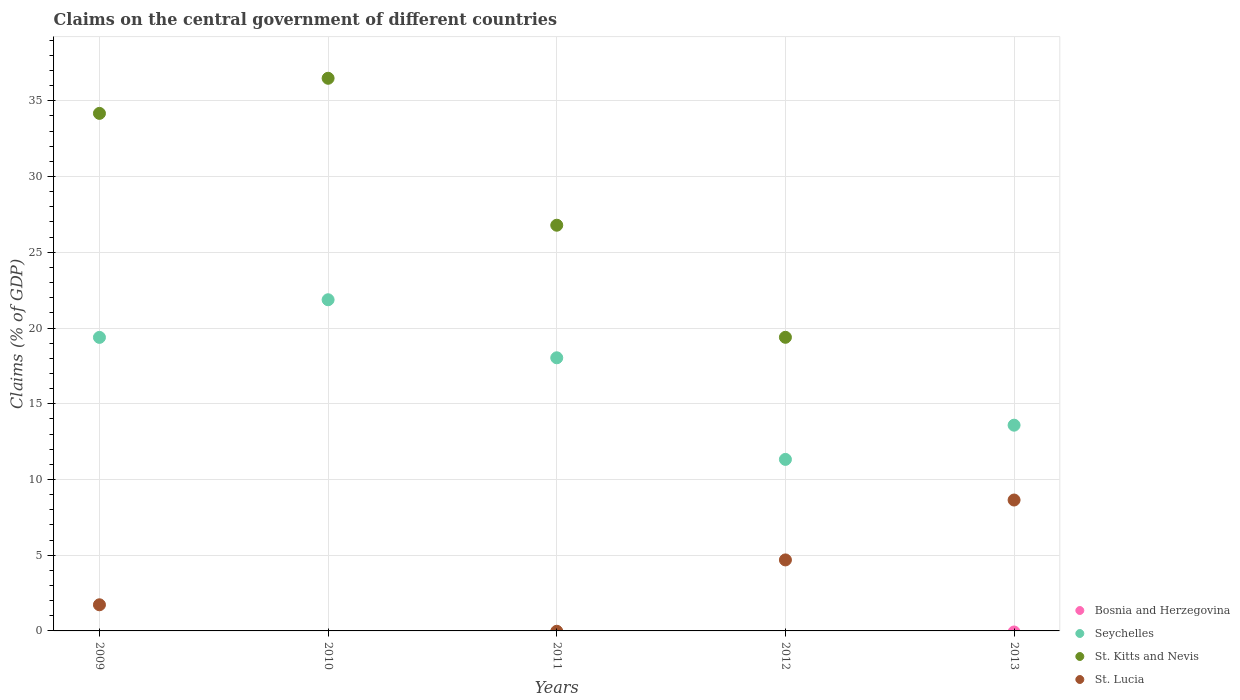How many different coloured dotlines are there?
Ensure brevity in your answer.  3. What is the percentage of GDP claimed on the central government in St. Kitts and Nevis in 2013?
Provide a short and direct response. 0. Across all years, what is the maximum percentage of GDP claimed on the central government in St. Lucia?
Ensure brevity in your answer.  8.64. Across all years, what is the minimum percentage of GDP claimed on the central government in St. Lucia?
Your answer should be compact. 0. What is the total percentage of GDP claimed on the central government in St. Lucia in the graph?
Provide a succinct answer. 15.06. What is the difference between the percentage of GDP claimed on the central government in Seychelles in 2011 and that in 2012?
Make the answer very short. 6.71. What is the difference between the percentage of GDP claimed on the central government in St. Lucia in 2011 and the percentage of GDP claimed on the central government in Bosnia and Herzegovina in 2012?
Ensure brevity in your answer.  0. What is the average percentage of GDP claimed on the central government in Seychelles per year?
Ensure brevity in your answer.  16.84. In the year 2012, what is the difference between the percentage of GDP claimed on the central government in Seychelles and percentage of GDP claimed on the central government in St. Lucia?
Provide a succinct answer. 6.64. In how many years, is the percentage of GDP claimed on the central government in Bosnia and Herzegovina greater than 5 %?
Provide a succinct answer. 0. What is the ratio of the percentage of GDP claimed on the central government in Seychelles in 2011 to that in 2012?
Your response must be concise. 1.59. Is the difference between the percentage of GDP claimed on the central government in Seychelles in 2009 and 2013 greater than the difference between the percentage of GDP claimed on the central government in St. Lucia in 2009 and 2013?
Provide a short and direct response. Yes. What is the difference between the highest and the second highest percentage of GDP claimed on the central government in Seychelles?
Offer a very short reply. 2.49. What is the difference between the highest and the lowest percentage of GDP claimed on the central government in St. Lucia?
Ensure brevity in your answer.  8.64. Is it the case that in every year, the sum of the percentage of GDP claimed on the central government in Bosnia and Herzegovina and percentage of GDP claimed on the central government in St. Lucia  is greater than the sum of percentage of GDP claimed on the central government in St. Kitts and Nevis and percentage of GDP claimed on the central government in Seychelles?
Keep it short and to the point. No. Does the percentage of GDP claimed on the central government in St. Lucia monotonically increase over the years?
Offer a very short reply. No. Is the percentage of GDP claimed on the central government in St. Lucia strictly greater than the percentage of GDP claimed on the central government in St. Kitts and Nevis over the years?
Ensure brevity in your answer.  No. Is the percentage of GDP claimed on the central government in Seychelles strictly less than the percentage of GDP claimed on the central government in St. Kitts and Nevis over the years?
Provide a succinct answer. No. What is the difference between two consecutive major ticks on the Y-axis?
Ensure brevity in your answer.  5. Are the values on the major ticks of Y-axis written in scientific E-notation?
Give a very brief answer. No. Does the graph contain any zero values?
Give a very brief answer. Yes. Where does the legend appear in the graph?
Give a very brief answer. Bottom right. What is the title of the graph?
Ensure brevity in your answer.  Claims on the central government of different countries. Does "Cambodia" appear as one of the legend labels in the graph?
Your answer should be very brief. No. What is the label or title of the Y-axis?
Your answer should be compact. Claims (% of GDP). What is the Claims (% of GDP) in Seychelles in 2009?
Your answer should be very brief. 19.38. What is the Claims (% of GDP) of St. Kitts and Nevis in 2009?
Your answer should be very brief. 34.17. What is the Claims (% of GDP) of St. Lucia in 2009?
Your response must be concise. 1.73. What is the Claims (% of GDP) in Seychelles in 2010?
Make the answer very short. 21.87. What is the Claims (% of GDP) of St. Kitts and Nevis in 2010?
Offer a very short reply. 36.49. What is the Claims (% of GDP) in St. Lucia in 2010?
Ensure brevity in your answer.  0. What is the Claims (% of GDP) of Bosnia and Herzegovina in 2011?
Provide a succinct answer. 0. What is the Claims (% of GDP) in Seychelles in 2011?
Offer a terse response. 18.03. What is the Claims (% of GDP) of St. Kitts and Nevis in 2011?
Offer a very short reply. 26.79. What is the Claims (% of GDP) of St. Lucia in 2011?
Make the answer very short. 0. What is the Claims (% of GDP) of Bosnia and Herzegovina in 2012?
Keep it short and to the point. 0. What is the Claims (% of GDP) of Seychelles in 2012?
Your response must be concise. 11.33. What is the Claims (% of GDP) in St. Kitts and Nevis in 2012?
Keep it short and to the point. 19.39. What is the Claims (% of GDP) of St. Lucia in 2012?
Ensure brevity in your answer.  4.69. What is the Claims (% of GDP) in Bosnia and Herzegovina in 2013?
Ensure brevity in your answer.  0. What is the Claims (% of GDP) in Seychelles in 2013?
Offer a very short reply. 13.58. What is the Claims (% of GDP) in St. Kitts and Nevis in 2013?
Your response must be concise. 0. What is the Claims (% of GDP) in St. Lucia in 2013?
Make the answer very short. 8.64. Across all years, what is the maximum Claims (% of GDP) of Seychelles?
Offer a very short reply. 21.87. Across all years, what is the maximum Claims (% of GDP) of St. Kitts and Nevis?
Your answer should be very brief. 36.49. Across all years, what is the maximum Claims (% of GDP) of St. Lucia?
Make the answer very short. 8.64. Across all years, what is the minimum Claims (% of GDP) of Seychelles?
Provide a succinct answer. 11.33. What is the total Claims (% of GDP) of Bosnia and Herzegovina in the graph?
Give a very brief answer. 0. What is the total Claims (% of GDP) in Seychelles in the graph?
Your response must be concise. 84.19. What is the total Claims (% of GDP) in St. Kitts and Nevis in the graph?
Provide a short and direct response. 116.83. What is the total Claims (% of GDP) of St. Lucia in the graph?
Give a very brief answer. 15.06. What is the difference between the Claims (% of GDP) of Seychelles in 2009 and that in 2010?
Offer a terse response. -2.49. What is the difference between the Claims (% of GDP) in St. Kitts and Nevis in 2009 and that in 2010?
Your answer should be compact. -2.32. What is the difference between the Claims (% of GDP) in Seychelles in 2009 and that in 2011?
Your answer should be compact. 1.35. What is the difference between the Claims (% of GDP) in St. Kitts and Nevis in 2009 and that in 2011?
Offer a very short reply. 7.38. What is the difference between the Claims (% of GDP) of Seychelles in 2009 and that in 2012?
Provide a short and direct response. 8.06. What is the difference between the Claims (% of GDP) of St. Kitts and Nevis in 2009 and that in 2012?
Your answer should be very brief. 14.78. What is the difference between the Claims (% of GDP) of St. Lucia in 2009 and that in 2012?
Offer a very short reply. -2.96. What is the difference between the Claims (% of GDP) of Seychelles in 2009 and that in 2013?
Make the answer very short. 5.8. What is the difference between the Claims (% of GDP) in St. Lucia in 2009 and that in 2013?
Your answer should be compact. -6.92. What is the difference between the Claims (% of GDP) in Seychelles in 2010 and that in 2011?
Keep it short and to the point. 3.83. What is the difference between the Claims (% of GDP) of St. Kitts and Nevis in 2010 and that in 2011?
Offer a terse response. 9.7. What is the difference between the Claims (% of GDP) in Seychelles in 2010 and that in 2012?
Provide a succinct answer. 10.54. What is the difference between the Claims (% of GDP) of St. Kitts and Nevis in 2010 and that in 2012?
Provide a succinct answer. 17.1. What is the difference between the Claims (% of GDP) of Seychelles in 2010 and that in 2013?
Give a very brief answer. 8.28. What is the difference between the Claims (% of GDP) of Seychelles in 2011 and that in 2012?
Ensure brevity in your answer.  6.71. What is the difference between the Claims (% of GDP) of St. Kitts and Nevis in 2011 and that in 2012?
Provide a succinct answer. 7.4. What is the difference between the Claims (% of GDP) in Seychelles in 2011 and that in 2013?
Your answer should be very brief. 4.45. What is the difference between the Claims (% of GDP) in Seychelles in 2012 and that in 2013?
Provide a short and direct response. -2.26. What is the difference between the Claims (% of GDP) of St. Lucia in 2012 and that in 2013?
Ensure brevity in your answer.  -3.95. What is the difference between the Claims (% of GDP) of Seychelles in 2009 and the Claims (% of GDP) of St. Kitts and Nevis in 2010?
Provide a succinct answer. -17.11. What is the difference between the Claims (% of GDP) of Seychelles in 2009 and the Claims (% of GDP) of St. Kitts and Nevis in 2011?
Ensure brevity in your answer.  -7.41. What is the difference between the Claims (% of GDP) in Seychelles in 2009 and the Claims (% of GDP) in St. Kitts and Nevis in 2012?
Keep it short and to the point. -0.01. What is the difference between the Claims (% of GDP) in Seychelles in 2009 and the Claims (% of GDP) in St. Lucia in 2012?
Offer a very short reply. 14.69. What is the difference between the Claims (% of GDP) in St. Kitts and Nevis in 2009 and the Claims (% of GDP) in St. Lucia in 2012?
Ensure brevity in your answer.  29.48. What is the difference between the Claims (% of GDP) in Seychelles in 2009 and the Claims (% of GDP) in St. Lucia in 2013?
Keep it short and to the point. 10.74. What is the difference between the Claims (% of GDP) in St. Kitts and Nevis in 2009 and the Claims (% of GDP) in St. Lucia in 2013?
Keep it short and to the point. 25.53. What is the difference between the Claims (% of GDP) of Seychelles in 2010 and the Claims (% of GDP) of St. Kitts and Nevis in 2011?
Your response must be concise. -4.92. What is the difference between the Claims (% of GDP) in Seychelles in 2010 and the Claims (% of GDP) in St. Kitts and Nevis in 2012?
Offer a very short reply. 2.48. What is the difference between the Claims (% of GDP) in Seychelles in 2010 and the Claims (% of GDP) in St. Lucia in 2012?
Your answer should be very brief. 17.18. What is the difference between the Claims (% of GDP) in St. Kitts and Nevis in 2010 and the Claims (% of GDP) in St. Lucia in 2012?
Provide a succinct answer. 31.8. What is the difference between the Claims (% of GDP) of Seychelles in 2010 and the Claims (% of GDP) of St. Lucia in 2013?
Your answer should be very brief. 13.22. What is the difference between the Claims (% of GDP) of St. Kitts and Nevis in 2010 and the Claims (% of GDP) of St. Lucia in 2013?
Provide a succinct answer. 27.85. What is the difference between the Claims (% of GDP) of Seychelles in 2011 and the Claims (% of GDP) of St. Kitts and Nevis in 2012?
Offer a terse response. -1.35. What is the difference between the Claims (% of GDP) of Seychelles in 2011 and the Claims (% of GDP) of St. Lucia in 2012?
Ensure brevity in your answer.  13.35. What is the difference between the Claims (% of GDP) of St. Kitts and Nevis in 2011 and the Claims (% of GDP) of St. Lucia in 2012?
Provide a short and direct response. 22.1. What is the difference between the Claims (% of GDP) of Seychelles in 2011 and the Claims (% of GDP) of St. Lucia in 2013?
Keep it short and to the point. 9.39. What is the difference between the Claims (% of GDP) in St. Kitts and Nevis in 2011 and the Claims (% of GDP) in St. Lucia in 2013?
Offer a terse response. 18.14. What is the difference between the Claims (% of GDP) in Seychelles in 2012 and the Claims (% of GDP) in St. Lucia in 2013?
Your answer should be very brief. 2.68. What is the difference between the Claims (% of GDP) in St. Kitts and Nevis in 2012 and the Claims (% of GDP) in St. Lucia in 2013?
Make the answer very short. 10.74. What is the average Claims (% of GDP) of Seychelles per year?
Your answer should be very brief. 16.84. What is the average Claims (% of GDP) of St. Kitts and Nevis per year?
Provide a short and direct response. 23.37. What is the average Claims (% of GDP) in St. Lucia per year?
Give a very brief answer. 3.01. In the year 2009, what is the difference between the Claims (% of GDP) of Seychelles and Claims (% of GDP) of St. Kitts and Nevis?
Keep it short and to the point. -14.79. In the year 2009, what is the difference between the Claims (% of GDP) of Seychelles and Claims (% of GDP) of St. Lucia?
Your response must be concise. 17.65. In the year 2009, what is the difference between the Claims (% of GDP) in St. Kitts and Nevis and Claims (% of GDP) in St. Lucia?
Provide a succinct answer. 32.44. In the year 2010, what is the difference between the Claims (% of GDP) of Seychelles and Claims (% of GDP) of St. Kitts and Nevis?
Provide a short and direct response. -14.62. In the year 2011, what is the difference between the Claims (% of GDP) in Seychelles and Claims (% of GDP) in St. Kitts and Nevis?
Ensure brevity in your answer.  -8.75. In the year 2012, what is the difference between the Claims (% of GDP) of Seychelles and Claims (% of GDP) of St. Kitts and Nevis?
Give a very brief answer. -8.06. In the year 2012, what is the difference between the Claims (% of GDP) in Seychelles and Claims (% of GDP) in St. Lucia?
Ensure brevity in your answer.  6.64. In the year 2012, what is the difference between the Claims (% of GDP) in St. Kitts and Nevis and Claims (% of GDP) in St. Lucia?
Offer a terse response. 14.7. In the year 2013, what is the difference between the Claims (% of GDP) of Seychelles and Claims (% of GDP) of St. Lucia?
Provide a short and direct response. 4.94. What is the ratio of the Claims (% of GDP) in Seychelles in 2009 to that in 2010?
Offer a terse response. 0.89. What is the ratio of the Claims (% of GDP) in St. Kitts and Nevis in 2009 to that in 2010?
Give a very brief answer. 0.94. What is the ratio of the Claims (% of GDP) of Seychelles in 2009 to that in 2011?
Your response must be concise. 1.07. What is the ratio of the Claims (% of GDP) in St. Kitts and Nevis in 2009 to that in 2011?
Ensure brevity in your answer.  1.28. What is the ratio of the Claims (% of GDP) in Seychelles in 2009 to that in 2012?
Make the answer very short. 1.71. What is the ratio of the Claims (% of GDP) of St. Kitts and Nevis in 2009 to that in 2012?
Your answer should be very brief. 1.76. What is the ratio of the Claims (% of GDP) in St. Lucia in 2009 to that in 2012?
Provide a short and direct response. 0.37. What is the ratio of the Claims (% of GDP) of Seychelles in 2009 to that in 2013?
Make the answer very short. 1.43. What is the ratio of the Claims (% of GDP) of St. Lucia in 2009 to that in 2013?
Give a very brief answer. 0.2. What is the ratio of the Claims (% of GDP) in Seychelles in 2010 to that in 2011?
Provide a succinct answer. 1.21. What is the ratio of the Claims (% of GDP) in St. Kitts and Nevis in 2010 to that in 2011?
Your response must be concise. 1.36. What is the ratio of the Claims (% of GDP) in Seychelles in 2010 to that in 2012?
Your answer should be very brief. 1.93. What is the ratio of the Claims (% of GDP) in St. Kitts and Nevis in 2010 to that in 2012?
Offer a very short reply. 1.88. What is the ratio of the Claims (% of GDP) in Seychelles in 2010 to that in 2013?
Provide a short and direct response. 1.61. What is the ratio of the Claims (% of GDP) of Seychelles in 2011 to that in 2012?
Ensure brevity in your answer.  1.59. What is the ratio of the Claims (% of GDP) of St. Kitts and Nevis in 2011 to that in 2012?
Make the answer very short. 1.38. What is the ratio of the Claims (% of GDP) of Seychelles in 2011 to that in 2013?
Keep it short and to the point. 1.33. What is the ratio of the Claims (% of GDP) of Seychelles in 2012 to that in 2013?
Ensure brevity in your answer.  0.83. What is the ratio of the Claims (% of GDP) of St. Lucia in 2012 to that in 2013?
Offer a terse response. 0.54. What is the difference between the highest and the second highest Claims (% of GDP) in Seychelles?
Provide a short and direct response. 2.49. What is the difference between the highest and the second highest Claims (% of GDP) of St. Kitts and Nevis?
Ensure brevity in your answer.  2.32. What is the difference between the highest and the second highest Claims (% of GDP) in St. Lucia?
Your response must be concise. 3.95. What is the difference between the highest and the lowest Claims (% of GDP) of Seychelles?
Your answer should be compact. 10.54. What is the difference between the highest and the lowest Claims (% of GDP) in St. Kitts and Nevis?
Provide a succinct answer. 36.49. What is the difference between the highest and the lowest Claims (% of GDP) of St. Lucia?
Give a very brief answer. 8.64. 